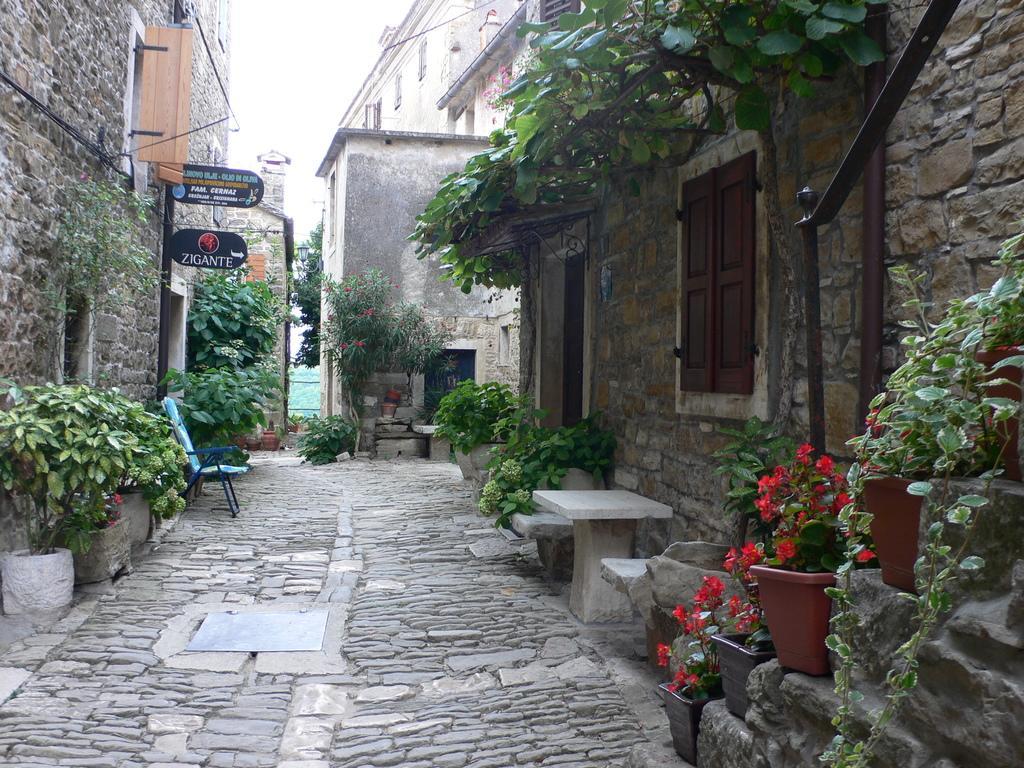In one or two sentences, can you explain what this image depicts? In this picture we can see the sky, buildings, boards, chair, planter, pots, windows and few objects. 